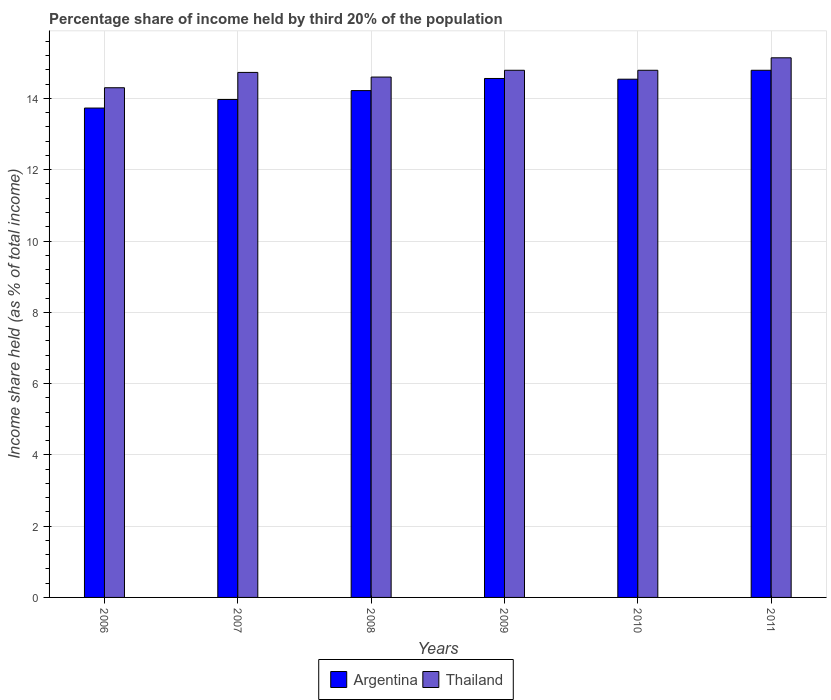How many groups of bars are there?
Offer a very short reply. 6. How many bars are there on the 4th tick from the right?
Your response must be concise. 2. What is the share of income held by third 20% of the population in Argentina in 2007?
Your answer should be very brief. 13.97. Across all years, what is the maximum share of income held by third 20% of the population in Thailand?
Your answer should be very brief. 15.14. What is the total share of income held by third 20% of the population in Thailand in the graph?
Offer a terse response. 88.35. What is the difference between the share of income held by third 20% of the population in Argentina in 2008 and that in 2010?
Your response must be concise. -0.32. What is the difference between the share of income held by third 20% of the population in Argentina in 2008 and the share of income held by third 20% of the population in Thailand in 2009?
Make the answer very short. -0.57. What is the average share of income held by third 20% of the population in Thailand per year?
Your answer should be very brief. 14.73. In the year 2009, what is the difference between the share of income held by third 20% of the population in Thailand and share of income held by third 20% of the population in Argentina?
Your response must be concise. 0.23. In how many years, is the share of income held by third 20% of the population in Argentina greater than 3.6 %?
Give a very brief answer. 6. What is the ratio of the share of income held by third 20% of the population in Argentina in 2008 to that in 2010?
Your answer should be compact. 0.98. What is the difference between the highest and the second highest share of income held by third 20% of the population in Argentina?
Provide a succinct answer. 0.23. What is the difference between the highest and the lowest share of income held by third 20% of the population in Argentina?
Ensure brevity in your answer.  1.06. What does the 2nd bar from the left in 2009 represents?
Give a very brief answer. Thailand. How many bars are there?
Your response must be concise. 12. How many years are there in the graph?
Ensure brevity in your answer.  6. Are the values on the major ticks of Y-axis written in scientific E-notation?
Your response must be concise. No. Does the graph contain grids?
Your answer should be very brief. Yes. How are the legend labels stacked?
Give a very brief answer. Horizontal. What is the title of the graph?
Your response must be concise. Percentage share of income held by third 20% of the population. What is the label or title of the X-axis?
Ensure brevity in your answer.  Years. What is the label or title of the Y-axis?
Your answer should be very brief. Income share held (as % of total income). What is the Income share held (as % of total income) in Argentina in 2006?
Offer a very short reply. 13.73. What is the Income share held (as % of total income) in Argentina in 2007?
Your answer should be very brief. 13.97. What is the Income share held (as % of total income) of Thailand in 2007?
Your answer should be compact. 14.73. What is the Income share held (as % of total income) of Argentina in 2008?
Provide a succinct answer. 14.22. What is the Income share held (as % of total income) in Thailand in 2008?
Your answer should be compact. 14.6. What is the Income share held (as % of total income) in Argentina in 2009?
Your response must be concise. 14.56. What is the Income share held (as % of total income) of Thailand in 2009?
Your answer should be compact. 14.79. What is the Income share held (as % of total income) of Argentina in 2010?
Provide a short and direct response. 14.54. What is the Income share held (as % of total income) in Thailand in 2010?
Make the answer very short. 14.79. What is the Income share held (as % of total income) in Argentina in 2011?
Offer a very short reply. 14.79. What is the Income share held (as % of total income) in Thailand in 2011?
Ensure brevity in your answer.  15.14. Across all years, what is the maximum Income share held (as % of total income) of Argentina?
Offer a very short reply. 14.79. Across all years, what is the maximum Income share held (as % of total income) in Thailand?
Give a very brief answer. 15.14. Across all years, what is the minimum Income share held (as % of total income) of Argentina?
Offer a terse response. 13.73. What is the total Income share held (as % of total income) in Argentina in the graph?
Your answer should be compact. 85.81. What is the total Income share held (as % of total income) in Thailand in the graph?
Give a very brief answer. 88.35. What is the difference between the Income share held (as % of total income) of Argentina in 2006 and that in 2007?
Offer a terse response. -0.24. What is the difference between the Income share held (as % of total income) of Thailand in 2006 and that in 2007?
Provide a succinct answer. -0.43. What is the difference between the Income share held (as % of total income) of Argentina in 2006 and that in 2008?
Make the answer very short. -0.49. What is the difference between the Income share held (as % of total income) of Thailand in 2006 and that in 2008?
Your answer should be very brief. -0.3. What is the difference between the Income share held (as % of total income) of Argentina in 2006 and that in 2009?
Your answer should be compact. -0.83. What is the difference between the Income share held (as % of total income) of Thailand in 2006 and that in 2009?
Your answer should be very brief. -0.49. What is the difference between the Income share held (as % of total income) of Argentina in 2006 and that in 2010?
Your response must be concise. -0.81. What is the difference between the Income share held (as % of total income) in Thailand in 2006 and that in 2010?
Your answer should be compact. -0.49. What is the difference between the Income share held (as % of total income) of Argentina in 2006 and that in 2011?
Ensure brevity in your answer.  -1.06. What is the difference between the Income share held (as % of total income) in Thailand in 2006 and that in 2011?
Provide a short and direct response. -0.84. What is the difference between the Income share held (as % of total income) of Argentina in 2007 and that in 2008?
Ensure brevity in your answer.  -0.25. What is the difference between the Income share held (as % of total income) in Thailand in 2007 and that in 2008?
Your answer should be compact. 0.13. What is the difference between the Income share held (as % of total income) in Argentina in 2007 and that in 2009?
Your answer should be very brief. -0.59. What is the difference between the Income share held (as % of total income) of Thailand in 2007 and that in 2009?
Ensure brevity in your answer.  -0.06. What is the difference between the Income share held (as % of total income) in Argentina in 2007 and that in 2010?
Give a very brief answer. -0.57. What is the difference between the Income share held (as % of total income) in Thailand in 2007 and that in 2010?
Make the answer very short. -0.06. What is the difference between the Income share held (as % of total income) of Argentina in 2007 and that in 2011?
Provide a succinct answer. -0.82. What is the difference between the Income share held (as % of total income) of Thailand in 2007 and that in 2011?
Offer a very short reply. -0.41. What is the difference between the Income share held (as % of total income) in Argentina in 2008 and that in 2009?
Provide a short and direct response. -0.34. What is the difference between the Income share held (as % of total income) in Thailand in 2008 and that in 2009?
Keep it short and to the point. -0.19. What is the difference between the Income share held (as % of total income) of Argentina in 2008 and that in 2010?
Keep it short and to the point. -0.32. What is the difference between the Income share held (as % of total income) in Thailand in 2008 and that in 2010?
Make the answer very short. -0.19. What is the difference between the Income share held (as % of total income) in Argentina in 2008 and that in 2011?
Offer a terse response. -0.57. What is the difference between the Income share held (as % of total income) of Thailand in 2008 and that in 2011?
Ensure brevity in your answer.  -0.54. What is the difference between the Income share held (as % of total income) in Argentina in 2009 and that in 2010?
Ensure brevity in your answer.  0.02. What is the difference between the Income share held (as % of total income) in Argentina in 2009 and that in 2011?
Your answer should be very brief. -0.23. What is the difference between the Income share held (as % of total income) in Thailand in 2009 and that in 2011?
Keep it short and to the point. -0.35. What is the difference between the Income share held (as % of total income) of Thailand in 2010 and that in 2011?
Make the answer very short. -0.35. What is the difference between the Income share held (as % of total income) of Argentina in 2006 and the Income share held (as % of total income) of Thailand in 2008?
Make the answer very short. -0.87. What is the difference between the Income share held (as % of total income) in Argentina in 2006 and the Income share held (as % of total income) in Thailand in 2009?
Ensure brevity in your answer.  -1.06. What is the difference between the Income share held (as % of total income) of Argentina in 2006 and the Income share held (as % of total income) of Thailand in 2010?
Make the answer very short. -1.06. What is the difference between the Income share held (as % of total income) of Argentina in 2006 and the Income share held (as % of total income) of Thailand in 2011?
Your answer should be compact. -1.41. What is the difference between the Income share held (as % of total income) in Argentina in 2007 and the Income share held (as % of total income) in Thailand in 2008?
Make the answer very short. -0.63. What is the difference between the Income share held (as % of total income) in Argentina in 2007 and the Income share held (as % of total income) in Thailand in 2009?
Offer a terse response. -0.82. What is the difference between the Income share held (as % of total income) in Argentina in 2007 and the Income share held (as % of total income) in Thailand in 2010?
Provide a succinct answer. -0.82. What is the difference between the Income share held (as % of total income) of Argentina in 2007 and the Income share held (as % of total income) of Thailand in 2011?
Provide a succinct answer. -1.17. What is the difference between the Income share held (as % of total income) of Argentina in 2008 and the Income share held (as % of total income) of Thailand in 2009?
Provide a succinct answer. -0.57. What is the difference between the Income share held (as % of total income) of Argentina in 2008 and the Income share held (as % of total income) of Thailand in 2010?
Give a very brief answer. -0.57. What is the difference between the Income share held (as % of total income) of Argentina in 2008 and the Income share held (as % of total income) of Thailand in 2011?
Make the answer very short. -0.92. What is the difference between the Income share held (as % of total income) in Argentina in 2009 and the Income share held (as % of total income) in Thailand in 2010?
Your answer should be very brief. -0.23. What is the difference between the Income share held (as % of total income) of Argentina in 2009 and the Income share held (as % of total income) of Thailand in 2011?
Ensure brevity in your answer.  -0.58. What is the difference between the Income share held (as % of total income) of Argentina in 2010 and the Income share held (as % of total income) of Thailand in 2011?
Offer a terse response. -0.6. What is the average Income share held (as % of total income) of Argentina per year?
Give a very brief answer. 14.3. What is the average Income share held (as % of total income) in Thailand per year?
Your answer should be very brief. 14.72. In the year 2006, what is the difference between the Income share held (as % of total income) of Argentina and Income share held (as % of total income) of Thailand?
Keep it short and to the point. -0.57. In the year 2007, what is the difference between the Income share held (as % of total income) in Argentina and Income share held (as % of total income) in Thailand?
Provide a succinct answer. -0.76. In the year 2008, what is the difference between the Income share held (as % of total income) in Argentina and Income share held (as % of total income) in Thailand?
Your answer should be compact. -0.38. In the year 2009, what is the difference between the Income share held (as % of total income) of Argentina and Income share held (as % of total income) of Thailand?
Make the answer very short. -0.23. In the year 2010, what is the difference between the Income share held (as % of total income) in Argentina and Income share held (as % of total income) in Thailand?
Offer a very short reply. -0.25. In the year 2011, what is the difference between the Income share held (as % of total income) in Argentina and Income share held (as % of total income) in Thailand?
Keep it short and to the point. -0.35. What is the ratio of the Income share held (as % of total income) in Argentina in 2006 to that in 2007?
Your answer should be very brief. 0.98. What is the ratio of the Income share held (as % of total income) in Thailand in 2006 to that in 2007?
Make the answer very short. 0.97. What is the ratio of the Income share held (as % of total income) of Argentina in 2006 to that in 2008?
Make the answer very short. 0.97. What is the ratio of the Income share held (as % of total income) in Thailand in 2006 to that in 2008?
Ensure brevity in your answer.  0.98. What is the ratio of the Income share held (as % of total income) in Argentina in 2006 to that in 2009?
Your answer should be very brief. 0.94. What is the ratio of the Income share held (as % of total income) of Thailand in 2006 to that in 2009?
Give a very brief answer. 0.97. What is the ratio of the Income share held (as % of total income) of Argentina in 2006 to that in 2010?
Keep it short and to the point. 0.94. What is the ratio of the Income share held (as % of total income) of Thailand in 2006 to that in 2010?
Provide a succinct answer. 0.97. What is the ratio of the Income share held (as % of total income) in Argentina in 2006 to that in 2011?
Offer a very short reply. 0.93. What is the ratio of the Income share held (as % of total income) in Thailand in 2006 to that in 2011?
Offer a terse response. 0.94. What is the ratio of the Income share held (as % of total income) in Argentina in 2007 to that in 2008?
Make the answer very short. 0.98. What is the ratio of the Income share held (as % of total income) of Thailand in 2007 to that in 2008?
Your answer should be compact. 1.01. What is the ratio of the Income share held (as % of total income) of Argentina in 2007 to that in 2009?
Make the answer very short. 0.96. What is the ratio of the Income share held (as % of total income) of Thailand in 2007 to that in 2009?
Ensure brevity in your answer.  1. What is the ratio of the Income share held (as % of total income) of Argentina in 2007 to that in 2010?
Give a very brief answer. 0.96. What is the ratio of the Income share held (as % of total income) of Argentina in 2007 to that in 2011?
Offer a terse response. 0.94. What is the ratio of the Income share held (as % of total income) in Thailand in 2007 to that in 2011?
Make the answer very short. 0.97. What is the ratio of the Income share held (as % of total income) of Argentina in 2008 to that in 2009?
Give a very brief answer. 0.98. What is the ratio of the Income share held (as % of total income) in Thailand in 2008 to that in 2009?
Provide a succinct answer. 0.99. What is the ratio of the Income share held (as % of total income) in Argentina in 2008 to that in 2010?
Your response must be concise. 0.98. What is the ratio of the Income share held (as % of total income) of Thailand in 2008 to that in 2010?
Give a very brief answer. 0.99. What is the ratio of the Income share held (as % of total income) in Argentina in 2008 to that in 2011?
Make the answer very short. 0.96. What is the ratio of the Income share held (as % of total income) in Thailand in 2008 to that in 2011?
Provide a succinct answer. 0.96. What is the ratio of the Income share held (as % of total income) in Argentina in 2009 to that in 2010?
Make the answer very short. 1. What is the ratio of the Income share held (as % of total income) in Argentina in 2009 to that in 2011?
Provide a succinct answer. 0.98. What is the ratio of the Income share held (as % of total income) of Thailand in 2009 to that in 2011?
Ensure brevity in your answer.  0.98. What is the ratio of the Income share held (as % of total income) of Argentina in 2010 to that in 2011?
Provide a succinct answer. 0.98. What is the ratio of the Income share held (as % of total income) in Thailand in 2010 to that in 2011?
Make the answer very short. 0.98. What is the difference between the highest and the second highest Income share held (as % of total income) in Argentina?
Provide a succinct answer. 0.23. What is the difference between the highest and the second highest Income share held (as % of total income) in Thailand?
Give a very brief answer. 0.35. What is the difference between the highest and the lowest Income share held (as % of total income) in Argentina?
Your answer should be compact. 1.06. What is the difference between the highest and the lowest Income share held (as % of total income) in Thailand?
Ensure brevity in your answer.  0.84. 